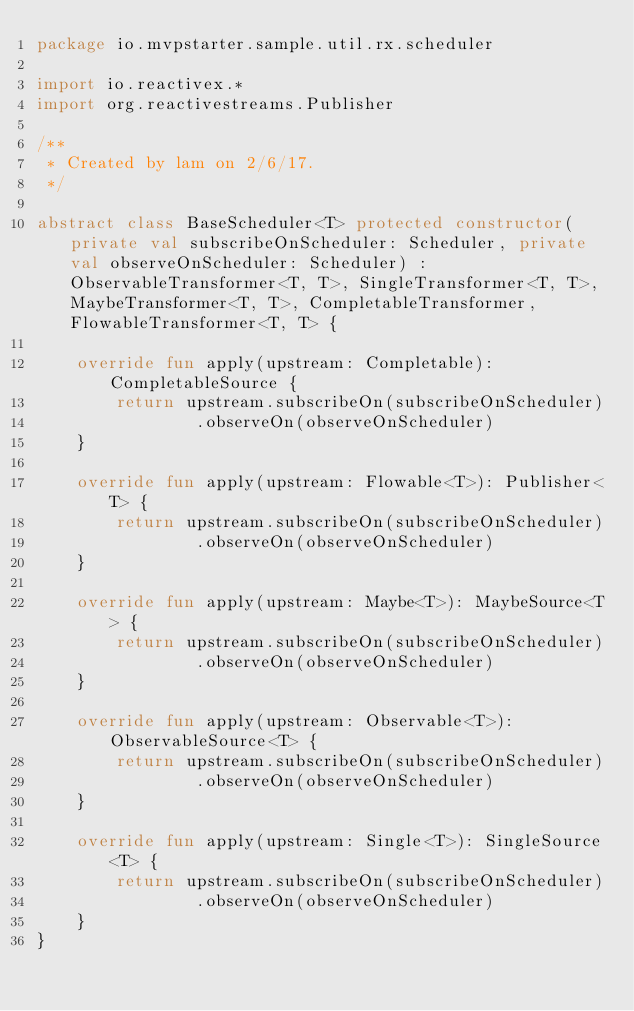Convert code to text. <code><loc_0><loc_0><loc_500><loc_500><_Kotlin_>package io.mvpstarter.sample.util.rx.scheduler

import io.reactivex.*
import org.reactivestreams.Publisher

/**
 * Created by lam on 2/6/17.
 */

abstract class BaseScheduler<T> protected constructor(private val subscribeOnScheduler: Scheduler, private val observeOnScheduler: Scheduler) : ObservableTransformer<T, T>, SingleTransformer<T, T>, MaybeTransformer<T, T>, CompletableTransformer, FlowableTransformer<T, T> {

    override fun apply(upstream: Completable): CompletableSource {
        return upstream.subscribeOn(subscribeOnScheduler)
                .observeOn(observeOnScheduler)
    }

    override fun apply(upstream: Flowable<T>): Publisher<T> {
        return upstream.subscribeOn(subscribeOnScheduler)
                .observeOn(observeOnScheduler)
    }

    override fun apply(upstream: Maybe<T>): MaybeSource<T> {
        return upstream.subscribeOn(subscribeOnScheduler)
                .observeOn(observeOnScheduler)
    }

    override fun apply(upstream: Observable<T>): ObservableSource<T> {
        return upstream.subscribeOn(subscribeOnScheduler)
                .observeOn(observeOnScheduler)
    }

    override fun apply(upstream: Single<T>): SingleSource<T> {
        return upstream.subscribeOn(subscribeOnScheduler)
                .observeOn(observeOnScheduler)
    }
}
</code> 